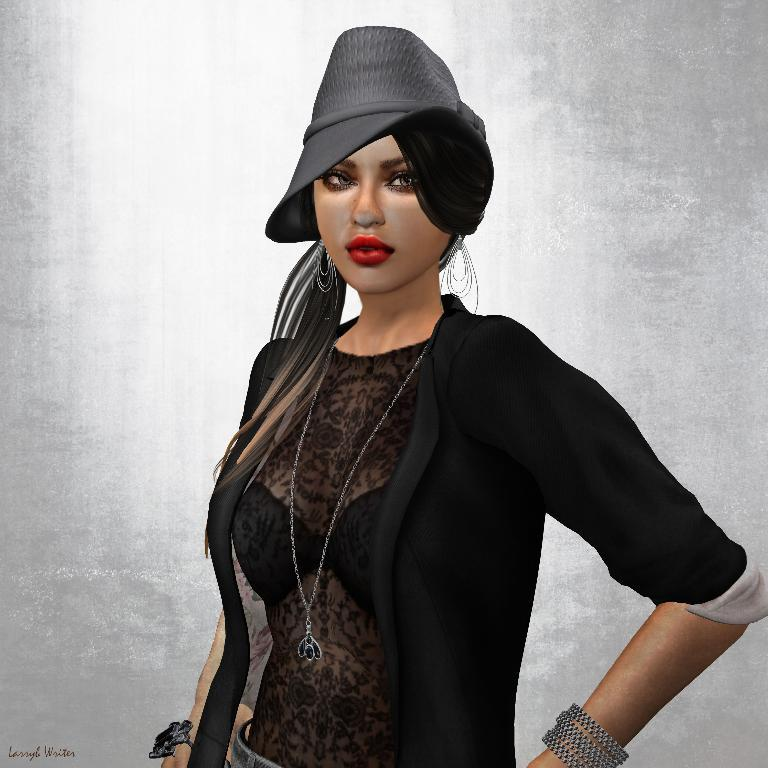What type of image is being described? The image is an animated picture. Who is the main subject in the image? There is a woman in the center of the image. What is the woman wearing? The woman is wearing a black dress and a black hat. What is the color of the background in the image? The background of the image is white. What type of brass instrument is the woman playing in the image? There is no brass instrument present in the image; the woman is not playing any musical instrument. What emotion does the woman express in the image, related to regret? The image does not convey any specific emotions, including regret, as it is an animated picture with a woman wearing a black dress and hat against a white background. 